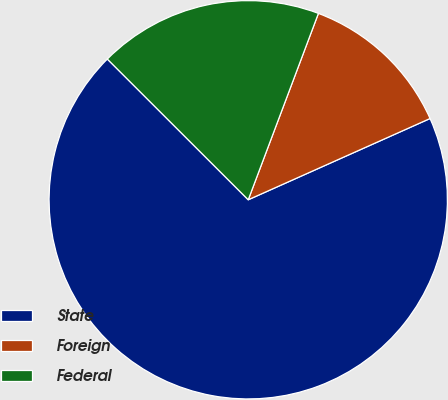<chart> <loc_0><loc_0><loc_500><loc_500><pie_chart><fcel>State<fcel>Foreign<fcel>Federal<nl><fcel>69.18%<fcel>12.58%<fcel>18.24%<nl></chart> 